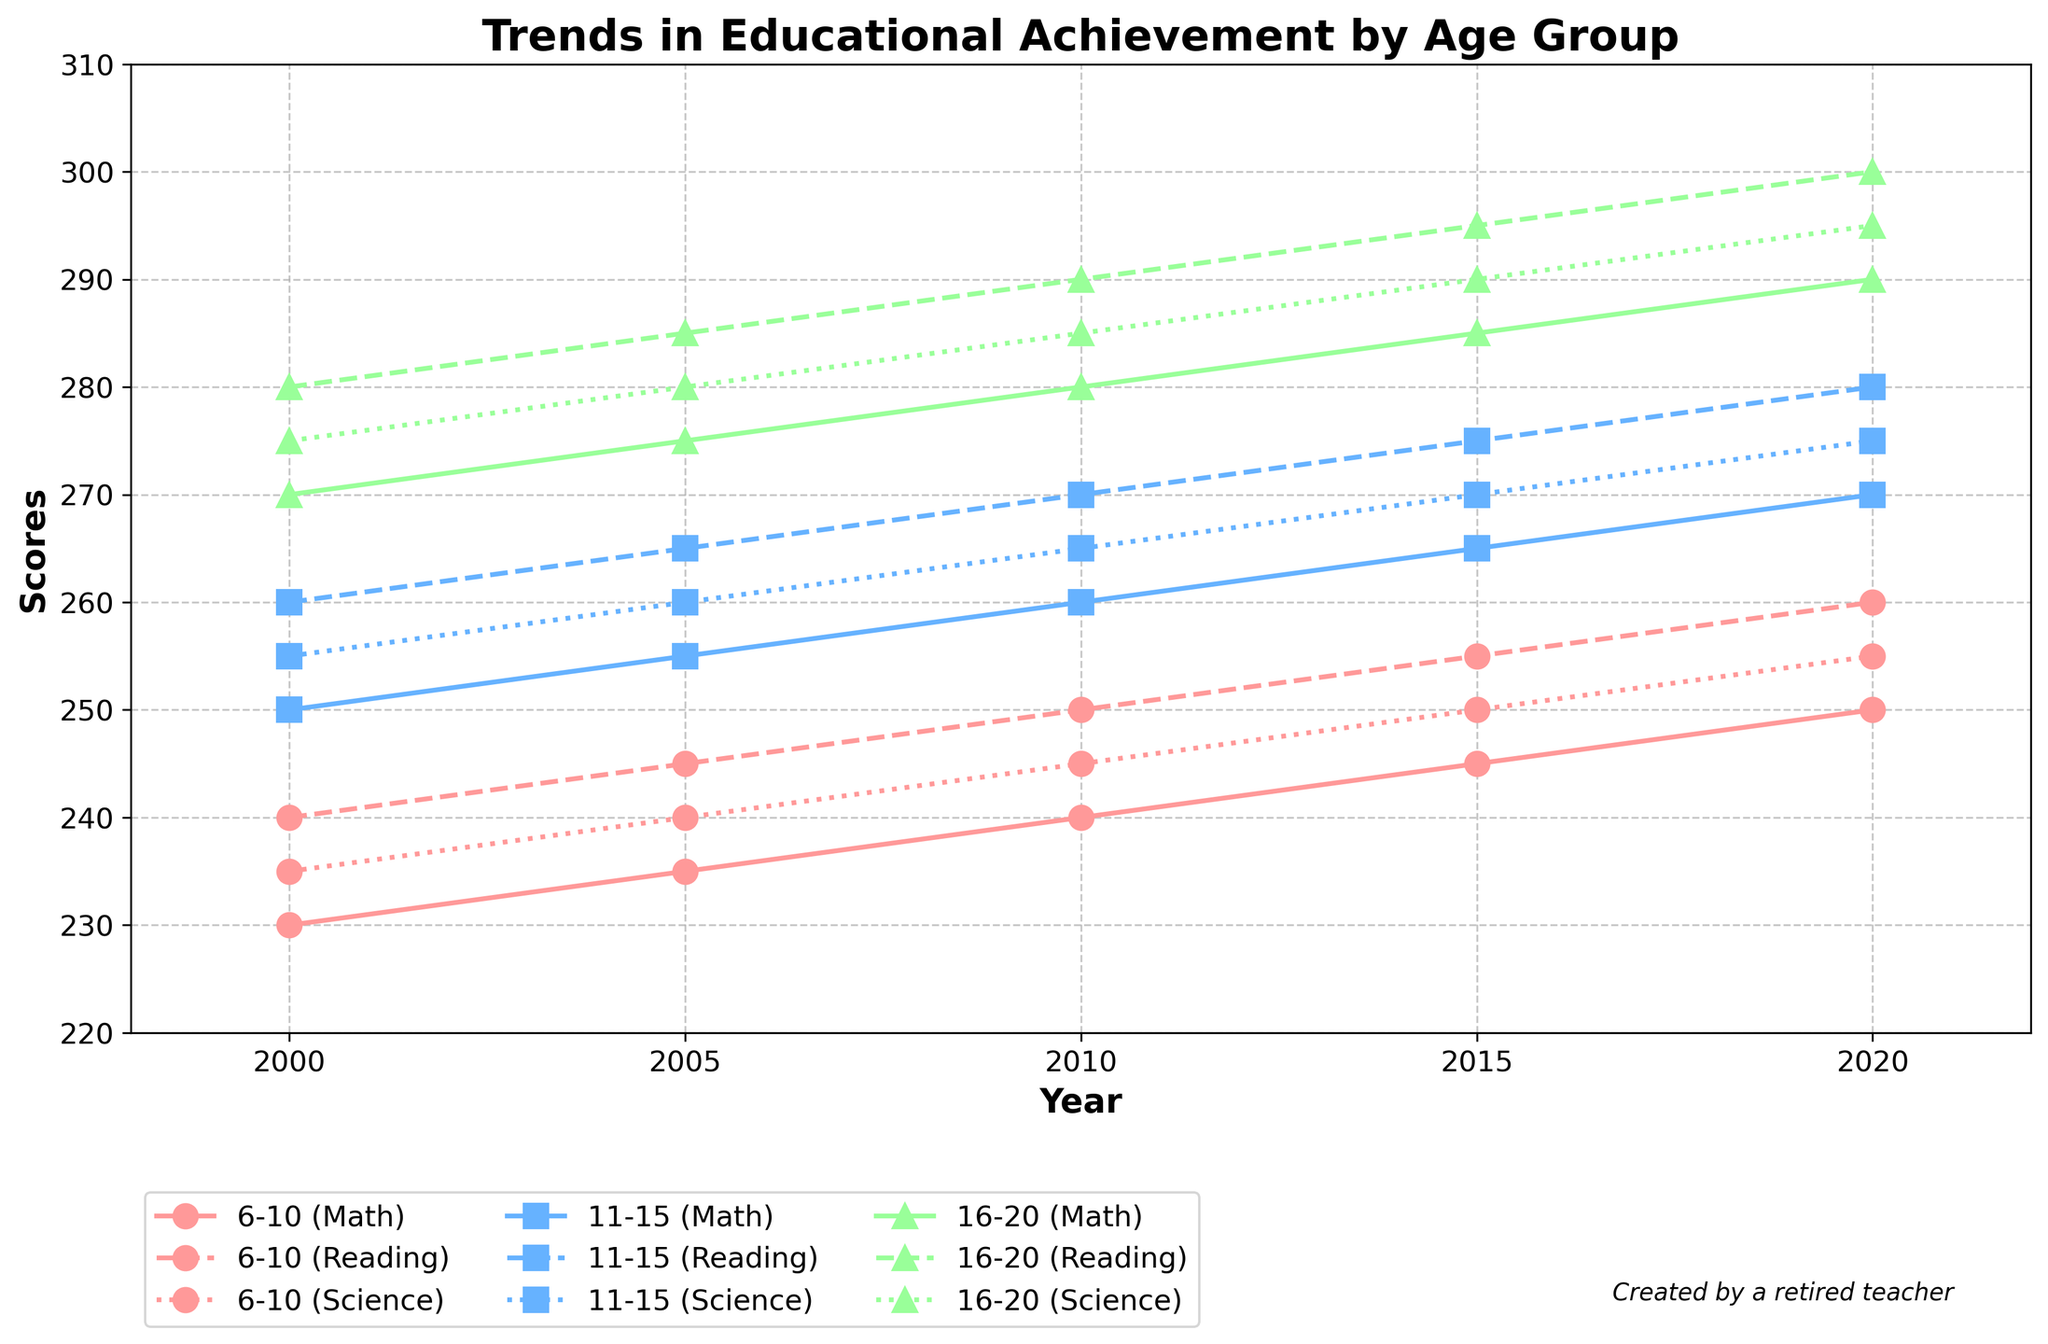What is the title of the plot? The title is displayed at the top of the plot.
Answer: Trends in Educational Achievement by Age Group What does the y-axis represent in the plot? The y-axis is labeled "Scores," which means it represents the academic scores in different subjects.
Answer: Scores Which age group shows the highest Math score in 2020? By looking at the Math scores of the different age groups in 2020, the age group 16-20 has the highest score.
Answer: 16-20 Between which years does the plot show data trends? The x-axis ranges from 2000 to 2020, indicating the data trends span these years.
Answer: 2000 to 2020 How do the Science scores for the 11-15 age group change from 2000 to 2010? By comparing the Science scores for the 11-15 age group in 2000 and 2010, we see they increase from 255 to 265.
Answer: Increase from 255 to 265 Which subject shows the highest score for the 6-10 age group in 2015? The scores for the 6-10 age group in 2015 are Math (245), Reading (255), and Science (250). Reading has the highest score.
Answer: Reading What is the difference in Reading scores between age groups 6-10 and 16-20 in 2015? The Reading score for the 6-10 age group in 2015 is 255, and for the 16-20 age group, it is 295. The difference is 295 - 255 = 40.
Answer: 40 Which age group has the most consistent increase in Math scores over the years? By examining the Math scores trend lines, the age group 16-20 consistently shows an increasing trend from 2000 to 2020 without any dips.
Answer: 16-20 How have the Math scores for the 6-10 age group changed from 2000 to 2020? By tracking the Math scores for the 6-10 age group from 2000 (230) to 2020 (250), the change is 250 - 230 = 20.
Answer: Increased by 20 Which age group has the highest overall scores in 2010? In 2010, the scores for the age group 16-20 are Math (280), Reading (290), and Science (285), which are higher overall compared to other age groups.
Answer: 16-20 